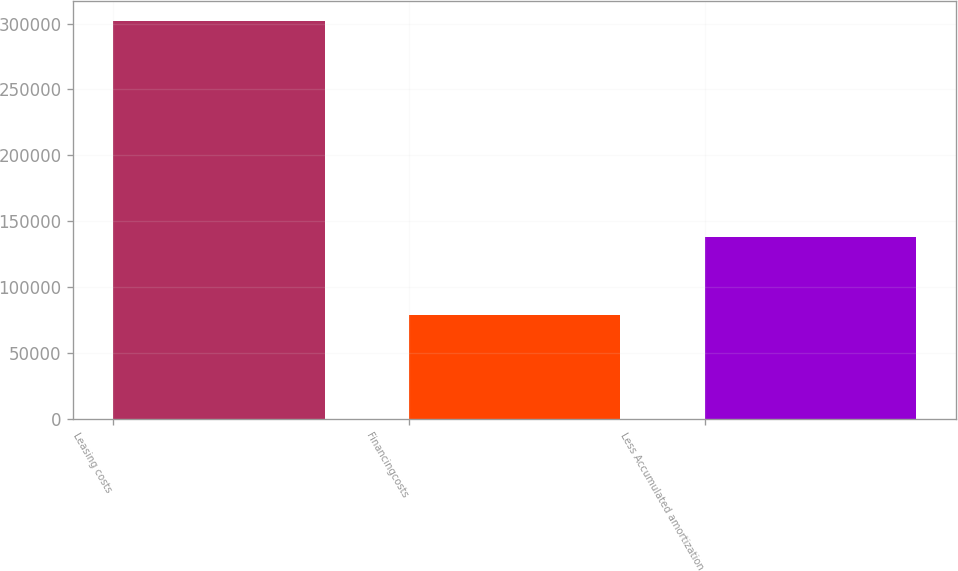Convert chart. <chart><loc_0><loc_0><loc_500><loc_500><bar_chart><fcel>Leasing costs<fcel>Financingcosts<fcel>Less Accumulated amortization<nl><fcel>302173<fcel>79032<fcel>138545<nl></chart> 